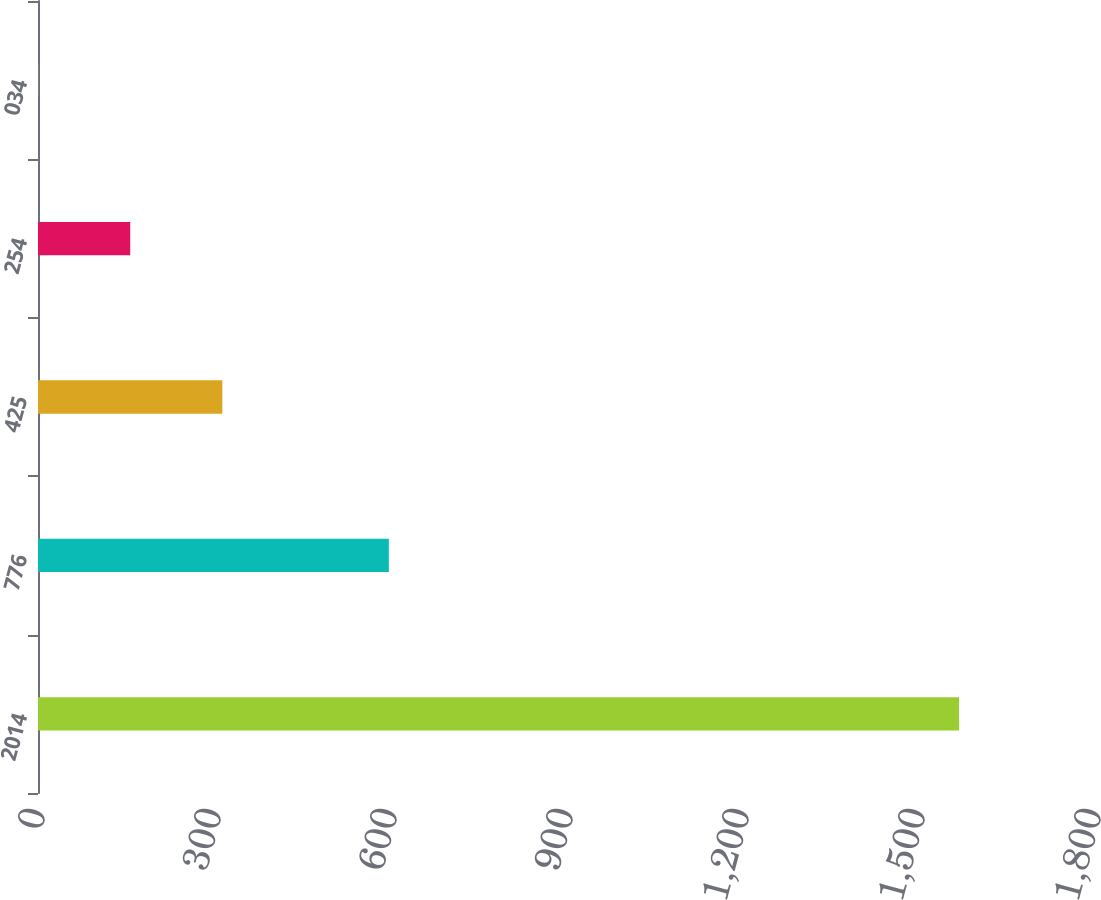Convert chart to OTSL. <chart><loc_0><loc_0><loc_500><loc_500><bar_chart><fcel>2014<fcel>776<fcel>425<fcel>254<fcel>034<nl><fcel>1570<fcel>598<fcel>314.16<fcel>157.18<fcel>0.2<nl></chart> 